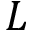Convert formula to latex. <formula><loc_0><loc_0><loc_500><loc_500>L</formula> 